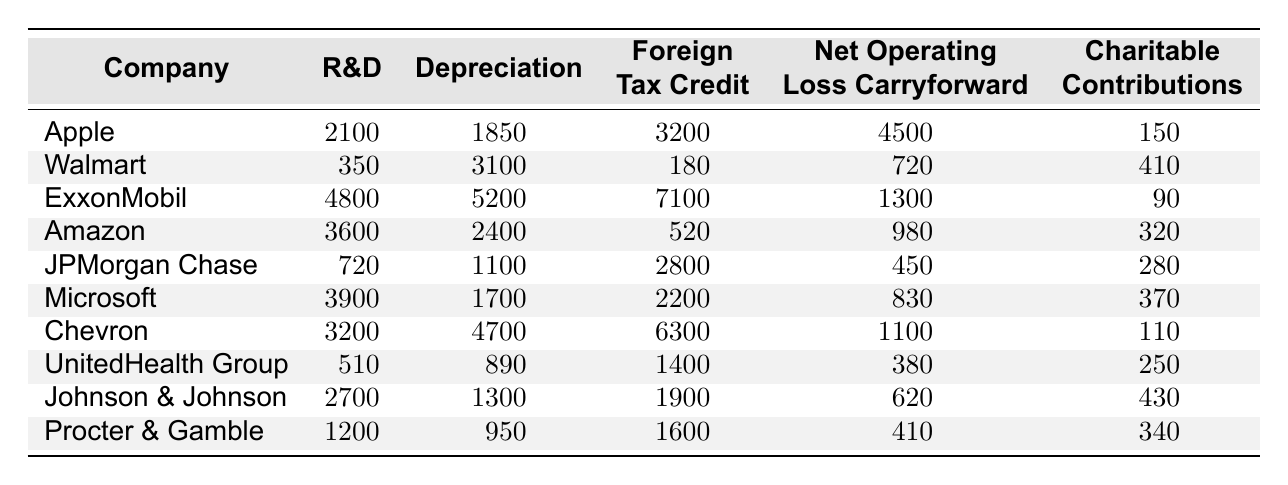What is the highest amount claimed for the Foreign Tax Credit? The Foreign Tax Credit values can be found in the corresponding column for each company. The highest value is 7100 claimed by ExxonMobil.
Answer: 7100 Which company has claimed the least amount for Charitable Contributions? By checking the values in the Charitable Contributions column, the least amount is 5, claimed by Walmart.
Answer: 5 What is the average amount claimed for Research and Development across all companies? The R&D values are: 2100, 350, 4800, 3600, 720, 3900, 3200, 510, 2700, and 1200. Adding these yields 20980. There are 10 companies, so the average is 20980/10 = 2098.
Answer: 2098 Which company has the highest total deductions? To find the total deductions for each company, sum all their deduction values. The totals are as follows: Apple (10375), Walmart (4085), ExxonMobil (16360), Amazon (6600), JPMorgan Chase (3890), Microsoft (4900), Chevron (8680), UnitedHealth Group (3080), Johnson & Johnson (4900), Procter & Gamble (4360). The highest total is from ExxonMobil.
Answer: ExxonMobil Is it true that Johnson & Johnson has claimed more in Depreciation than Apple? Checking the values, Johnson & Johnson has claimed 1300 and Apple 1850 in Depreciation. Since 1300 is less than 1850, the statement is false.
Answer: No What is the total amount claimed for Net Operating Loss Carryforward by the company with the highest claim in that deduction? The highest claim for Net Operating Loss Carryforward is 4500 by Apple. Therefore, the total claimed for this deduction by Apple is simply 4500.
Answer: 4500 Which company has made the most claims in Energy-Efficient Commercial Building Deduction? The values for this deduction are: 210, 40, 350, 70, 130, 180, 270, 90, 150, and 110. The highest value is 350, claimed by ExxonMobil.
Answer: ExxonMobil If the total Charitable Contributions across all companies were equally distributed among the ten companies, what would each receive? The total amount claimed for Charitable Contributions is 150 + 410 + 90 + 320 + 280 + 370 + 110 + 250 + 430 + 340 = 2260. Dividing this by 10 gives 226.
Answer: 226 Does Chevron have a higher claim for Depreciation compared to Microsoft? Chevron claims 4700 for Depreciation while Microsoft claims 1700. Since 4700 is greater than 1700, the statement is true.
Answer: Yes If a company claimed 2000 for Domestic Production Activities Deduction, what would the total deductions amount for that company be? The total deductions for each company are calculated by summing all their claims. Since the Domestic Production Activities Deduction wasn't provided in the data, we can't directly determine this without the additional data. However, assuming the company claimed 2000 in this category, the overall amount depends on their other claims.
Answer: Cannot determine without additional data 